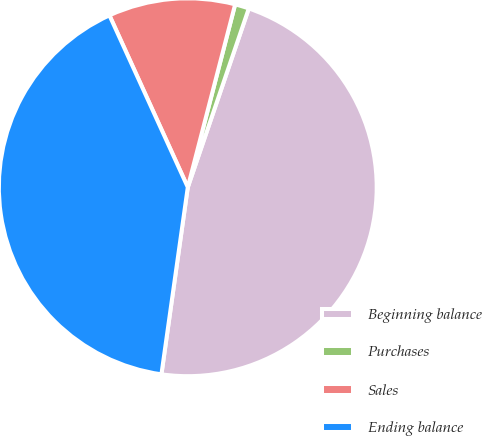Convert chart to OTSL. <chart><loc_0><loc_0><loc_500><loc_500><pie_chart><fcel>Beginning balance<fcel>Purchases<fcel>Sales<fcel>Ending balance<nl><fcel>46.99%<fcel>1.2%<fcel>10.84%<fcel>40.96%<nl></chart> 